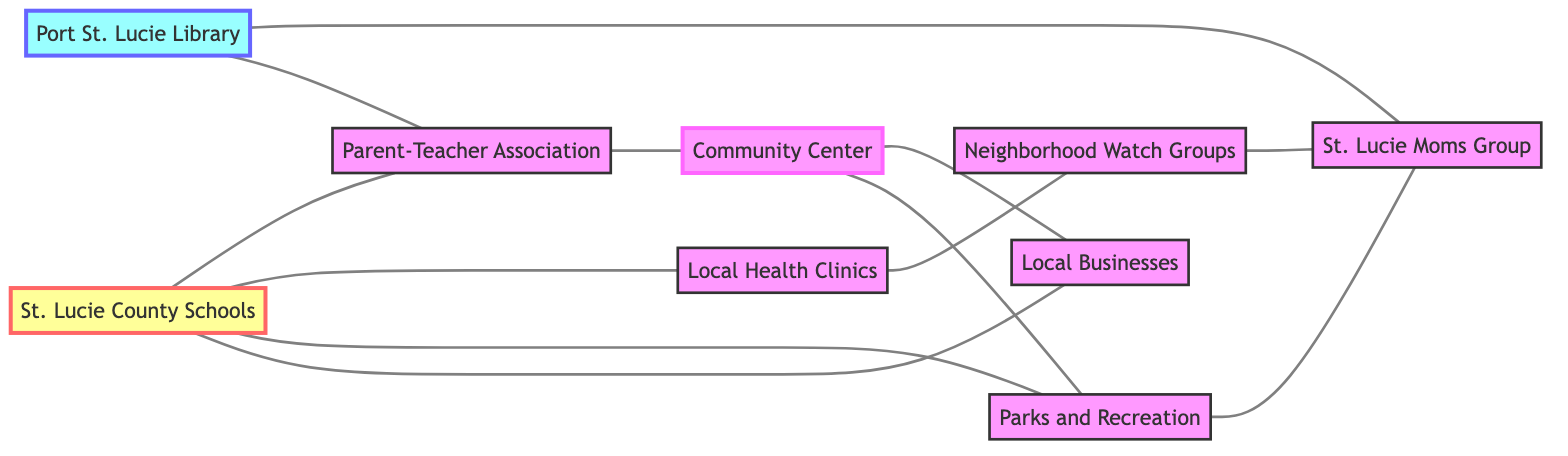What are the total number of nodes in the diagram? To find the total number of nodes, we simply count each unique entity listed in the "nodes" section of the data. There are 9 nodes: St. Lucie County Schools, Port St. Lucie Library, Parent-Teacher Association, Local Health Clinics, Community Center, Neighborhood Watch Groups, Local Businesses, Parks and Recreation, and St. Lucie Moms Group.
Answer: 9 Which node is connected directly to St. Lucie County Schools? We check the edges connected to the node "St. Lucie County Schools". It is connected directly to the Parent-Teacher Association, Local Health Clinics, and Parks and Recreation.
Answer: Parent-Teacher Association, Local Health Clinics, Parks and Recreation What is the relationship between the Community Center and Local Businesses? To determine the relationship, we look for edges connecting these two nodes. Upon inspection, there is a direct edge from Community Center to Local Businesses which indicates a direct relationship.
Answer: Directly connected How many connections does the Port St. Lucie Library have? We look at the edges associated with the Port St. Lucie Library node. It is connected to the St. Lucie Moms Group and Parent-Teacher Association, totaling 2 connections.
Answer: 2 Which node is the most connected in the diagram? To find the most connected node, we count the number of edges connecting to each node. The Community Center is connected to Local Health Clinics, Parent-Teacher Association, and Local Businesses, totaling 3 connections, making it the most connected node in the graph.
Answer: Community Center Is there a path connecting Neighborhood Watch Groups and St. Lucie Moms Group? We need to trace a path between these two nodes through the edges of the graph. Analyzing the connections, Neighborhood Watch Groups connects to Local Health Clinics, which connects to St. Lucie Moms Group, thus indicating an indirect path.
Answer: Yes How many edges are there connecting the Local Health Clinics? We inspect the edges to find how many times the Local Health Clinics node appears. It is connected to St. Lucie County Schools and Neighborhood Watch Groups, giving it a total of 2 edges.
Answer: 2 What nodes are connected through the Community Center? We look at the edges related to the Community Center. It connects to the Parent-Teacher Association, Local Businesses, and Parks and Recreation. So, the nodes connected through the Community Center are Parent-Teacher Association, Local Businesses, and Parks and Recreation.
Answer: Parent-Teacher Association, Local Businesses, Parks and Recreation Which two nodes have the least number of direct connections? To find the nodes with the least connections, we count the edges for each node. The Local Health Clinics and St. Lucie Moms Group each have only 2 connections, making them the nodes with the least direct connections.
Answer: Local Health Clinics, St. Lucie Moms Group 